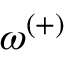<formula> <loc_0><loc_0><loc_500><loc_500>\omega ^ { ( + ) }</formula> 